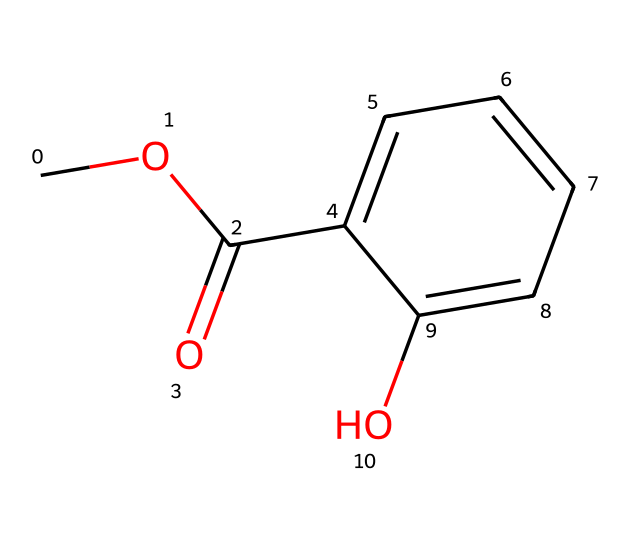What is the molecular formula of methyl salicylate? To derive the molecular formula, we count the number of each type of atom in the structure based on the SMILES representation. For methyl salicylate, the atoms present are 9 carbons, 10 hydrogens, and 4 oxygens. Therefore, the formula is C9H10O4.
Answer: C9H10O4 How many aromatic rings are present in the structure? By examining the structure indicated by the SMILES, we can identify the presence of a benzene-like ring (aromatic ring). There is one aromatic ring present in methyl salicylate.
Answer: 1 What type of functional group is present in methyl salicylate? In the molecule, we can identify a carbonyl group (C=O) adjacent to an ether (C-O-C) and a hydroxyl group (OH), indicating the presence of an ester functional group. The presence of the carboxylate bond confirms it is indeed an ester.
Answer: ester How many total atoms are in methyl salicylate? To find the total number of atoms, we sum up the individual atoms: 9 carbons, 10 hydrogens, and 4 oxygens. Adding these together gives a total of 23 atoms.
Answer: 23 What are the hydroxyl substituents in this ester? The hydroxyl group is represented by the -OH moiety present in the structure, which indicates the presence of a phenolic hydroxyl group resulting from the salicylic acid component. This contributes to the properties of the ester.
Answer: phenolic hydroxyl group What is the role of the methyl group in methyl salicylate? The methyl group (-CH3) in methyl salicylate plays a role in making the molecule an ester. It is attached to the carboxylate portion of the molecule, influencing its solubility and volatility characteristics.
Answer: influencing solubility Is methyl salicylate considered a volatile compound? Yes, methyl salicylate has a low molecular weight and evaporates easily, due to its structure and presence of alkyl groups. This makes it volatile, contributing to its aroma and effectiveness in topical applications.
Answer: yes 